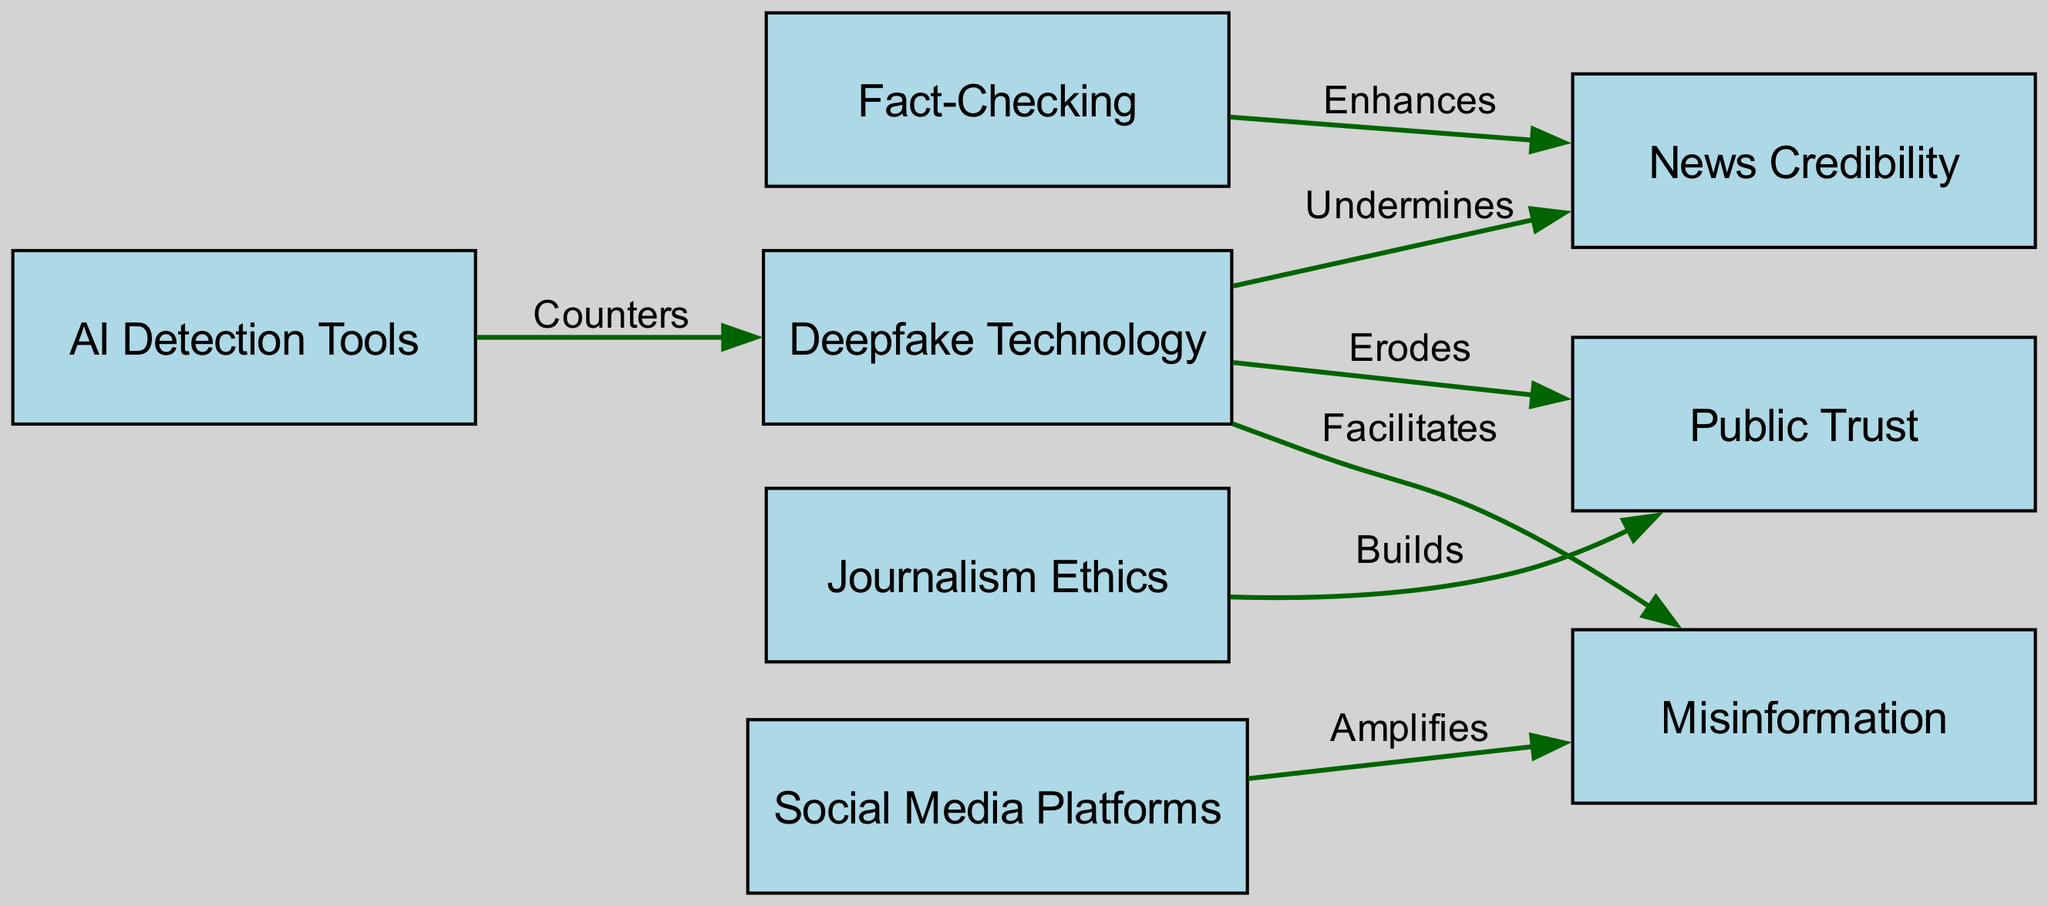What are the main effects of deepfake technology on public trust? The diagram shows that deepfake technology erodes public trust, indicating its impact on how people perceive information credibility.
Answer: Erodes How many nodes are present in the diagram? By counting all the unique nodes listed in the diagram—Deepfake Technology, News Credibility, Public Trust, Misinformation, Fact-Checking, Social Media Platforms, Journalism Ethics, and AI Detection Tools—we find there are a total of eight nodes.
Answer: Eight What does fact-checking enhance according to the diagram? The diagram clearly indicates that fact-checking enhances news credibility, pointing to its role in verifying the accuracy of information.
Answer: News Credibility Which node amplifies misinformation in the diagram? The diagram explicitly shows that social media platforms amplify misinformation, suggesting their significant role in spreading unverified content.
Answer: Social Media Platforms How does AI detection relate to deepfake technology? The diagram details that AI detection tools counter deepfake technology, indicating their effectiveness in identifying and mitigating deepfake content.
Answer: Counters What is the relationship between journalism ethics and public trust? According to the diagram, journalism ethics builds public trust, suggesting that ethical practices in journalism foster greater confidence among the audience.
Answer: Builds What does deepfake technology facilitate in the context of the diagram? The diagram demonstrates that deepfake technology facilitates misinformation, illustrating its contribution to the spread of false information.
Answer: Misinformation List all the edges originating from the deepfake node. The edges originating from the deepfake node are: "Undermines" News Credibility, "Erodes" Public Trust, and "Facilitates" Misinformation, describing the different ways deepfake technology impacts these aspects.
Answer: Undermines, Erodes, Facilitates Which node directly enhances news credibility? The diagram indicates that fact-checking directly enhances news credibility, showing its importance in maintaining accurate information.
Answer: Fact-Checking 